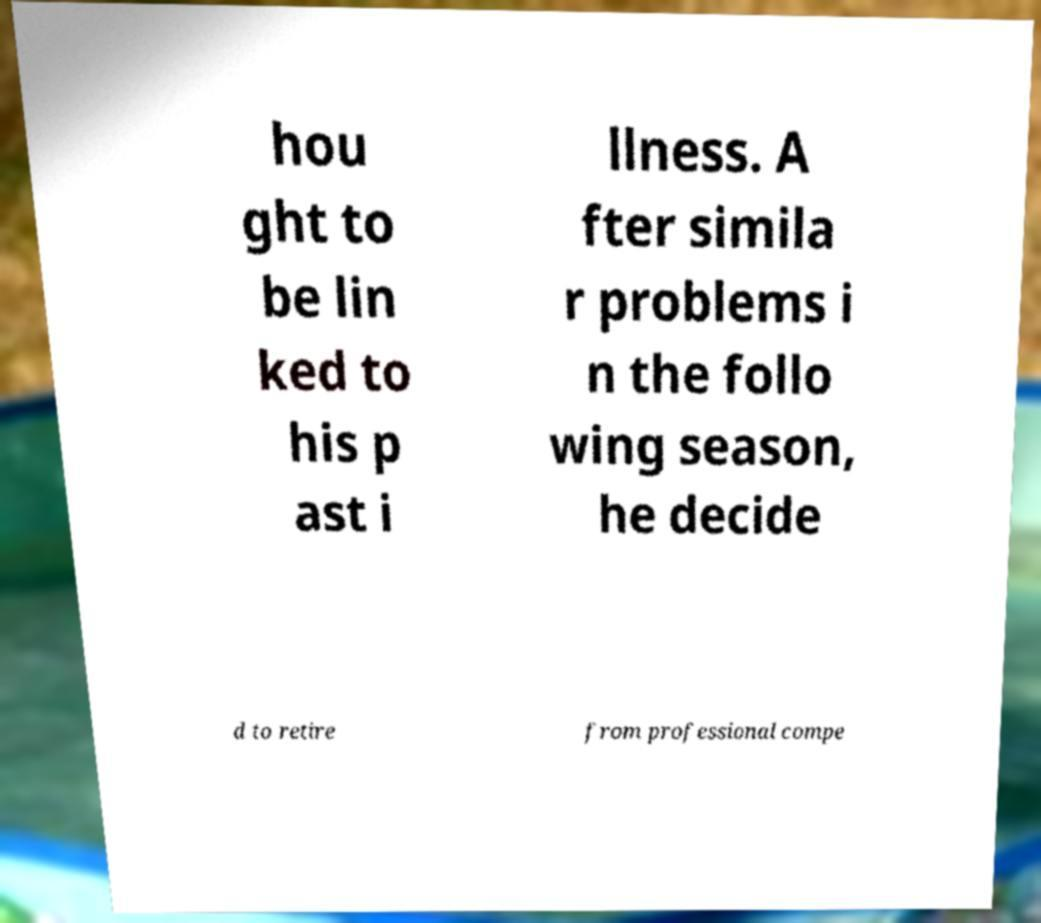What messages or text are displayed in this image? I need them in a readable, typed format. hou ght to be lin ked to his p ast i llness. A fter simila r problems i n the follo wing season, he decide d to retire from professional compe 